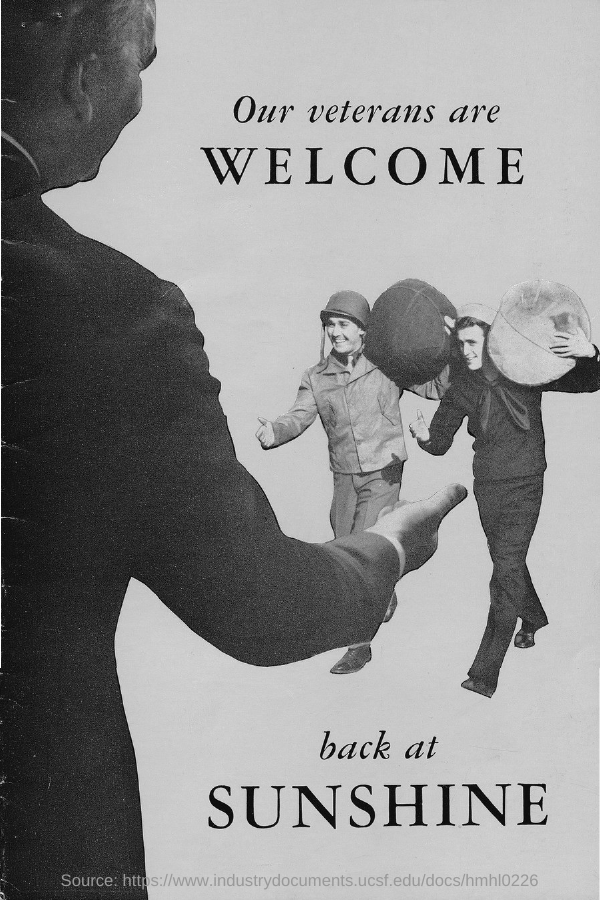Outline some significant characteristics in this image. The title of the document is 'Our veterans are welcome.' 